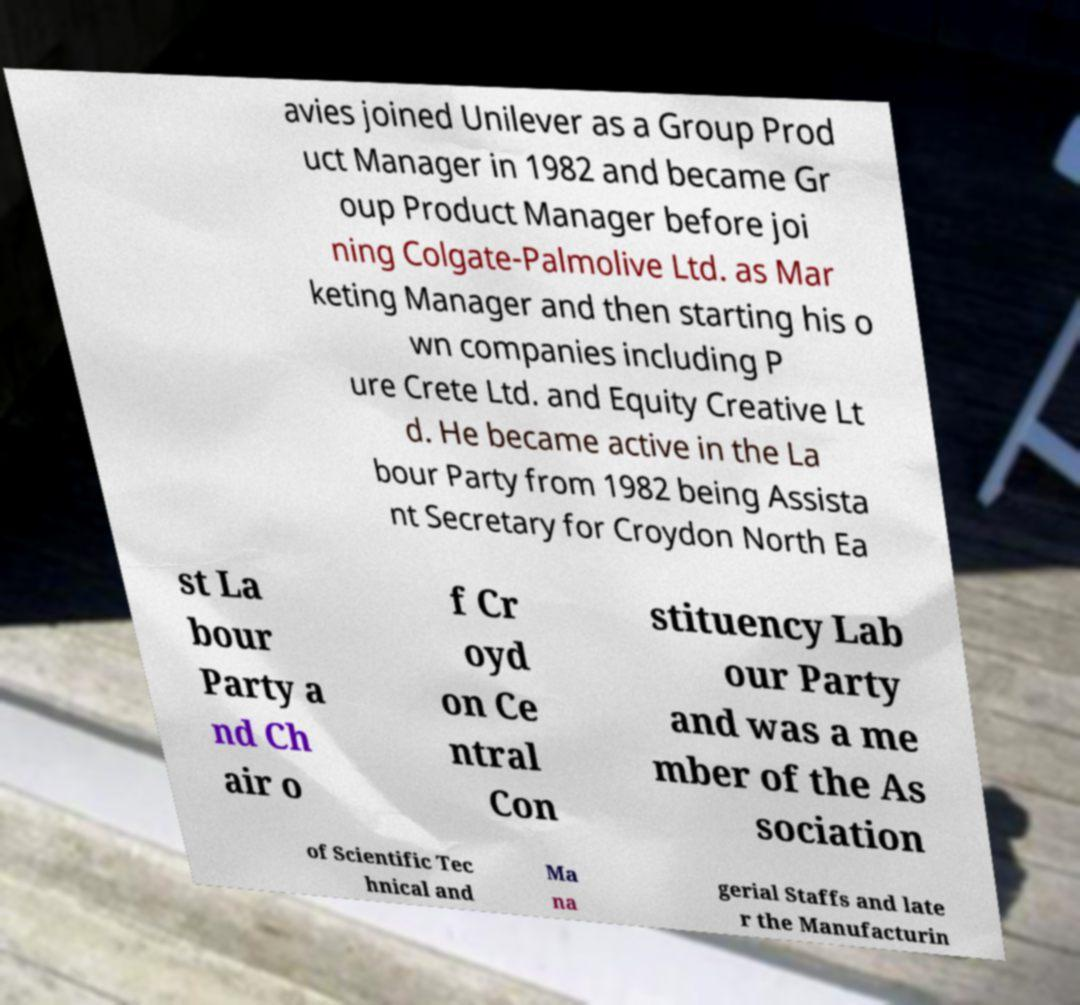Can you accurately transcribe the text from the provided image for me? avies joined Unilever as a Group Prod uct Manager in 1982 and became Gr oup Product Manager before joi ning Colgate-Palmolive Ltd. as Mar keting Manager and then starting his o wn companies including P ure Crete Ltd. and Equity Creative Lt d. He became active in the La bour Party from 1982 being Assista nt Secretary for Croydon North Ea st La bour Party a nd Ch air o f Cr oyd on Ce ntral Con stituency Lab our Party and was a me mber of the As sociation of Scientific Tec hnical and Ma na gerial Staffs and late r the Manufacturin 